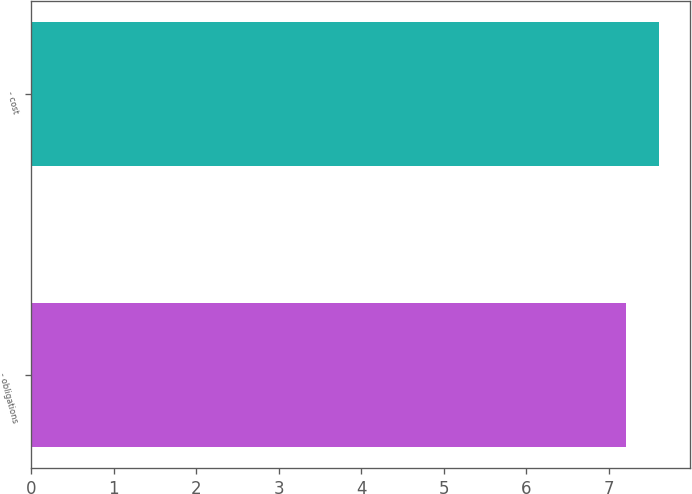Convert chart to OTSL. <chart><loc_0><loc_0><loc_500><loc_500><bar_chart><fcel>- obligations<fcel>- cost<nl><fcel>7.2<fcel>7.6<nl></chart> 